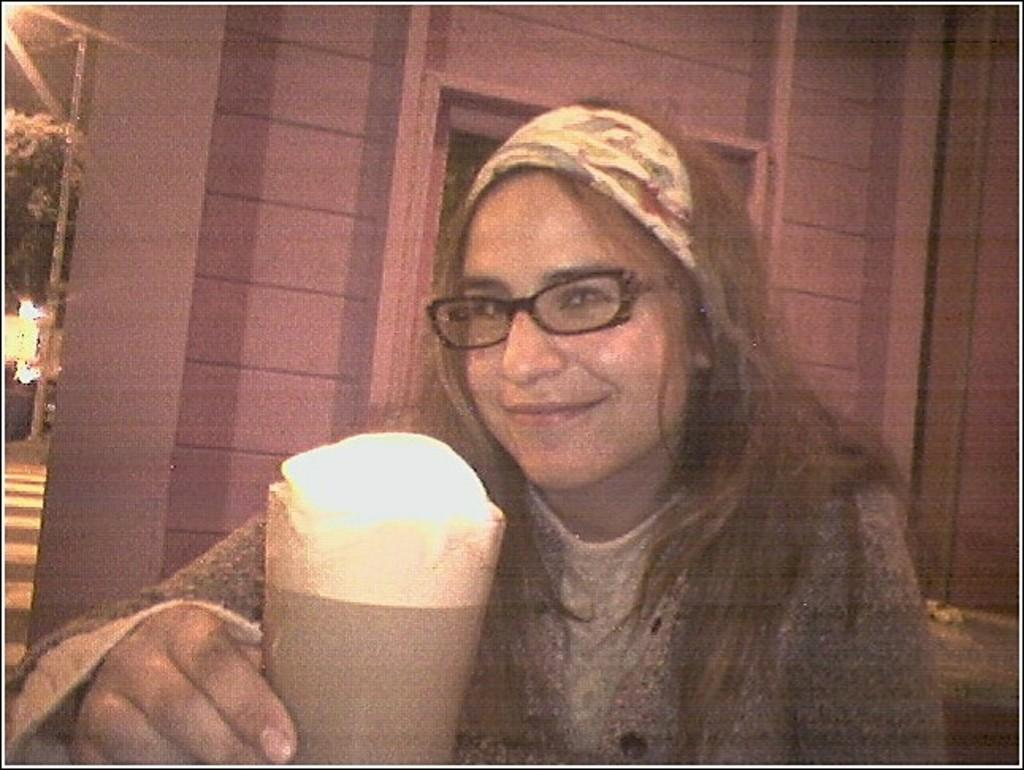Who is present in the image? There is a person in the image. What is the person's expression? The person is smiling. What is located in front of the person? A: There is a glass in front of the person. What is visible behind the person? There is a wall behind the person. What can be seen on the left side of the image? There are trees and lights on the left side of the image. What type of plastic is the person using for digestion in the image? There is no plastic or reference to digestion present in the image. 